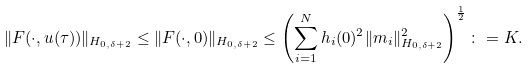Convert formula to latex. <formula><loc_0><loc_0><loc_500><loc_500>\| F ( \cdot , u ( \tau ) ) \| _ { H _ { 0 , \delta + 2 } } \leq \| F ( \cdot , 0 ) \| _ { H _ { 0 , \delta + 2 } } \leq \left ( \sum _ { i = 1 } ^ { N } h _ { i } ( 0 ) ^ { 2 } \| m _ { i } \| _ { H _ { 0 , \delta + 2 } } ^ { 2 } \right ) ^ { \frac { 1 } { 2 } } \colon = K .</formula> 